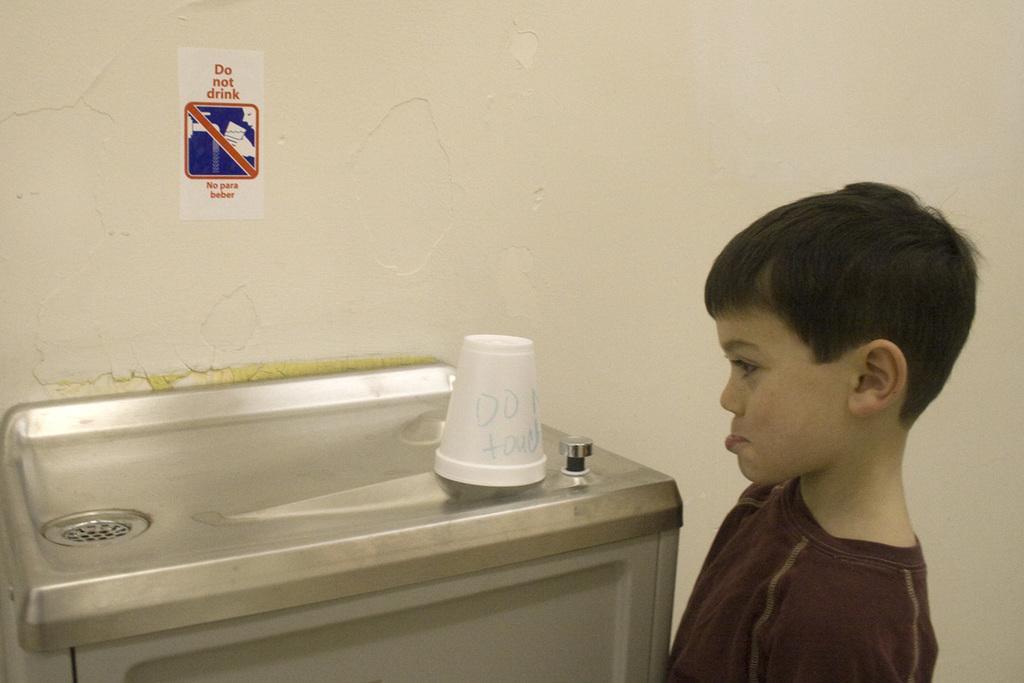How would you summarize this image in a sentence or two? In the picture I can see a kid standing in the right corner and there is a glass which has something written on it is placed on an object and there is a sticker which has some thing written on it is attached to the wall in the background. 